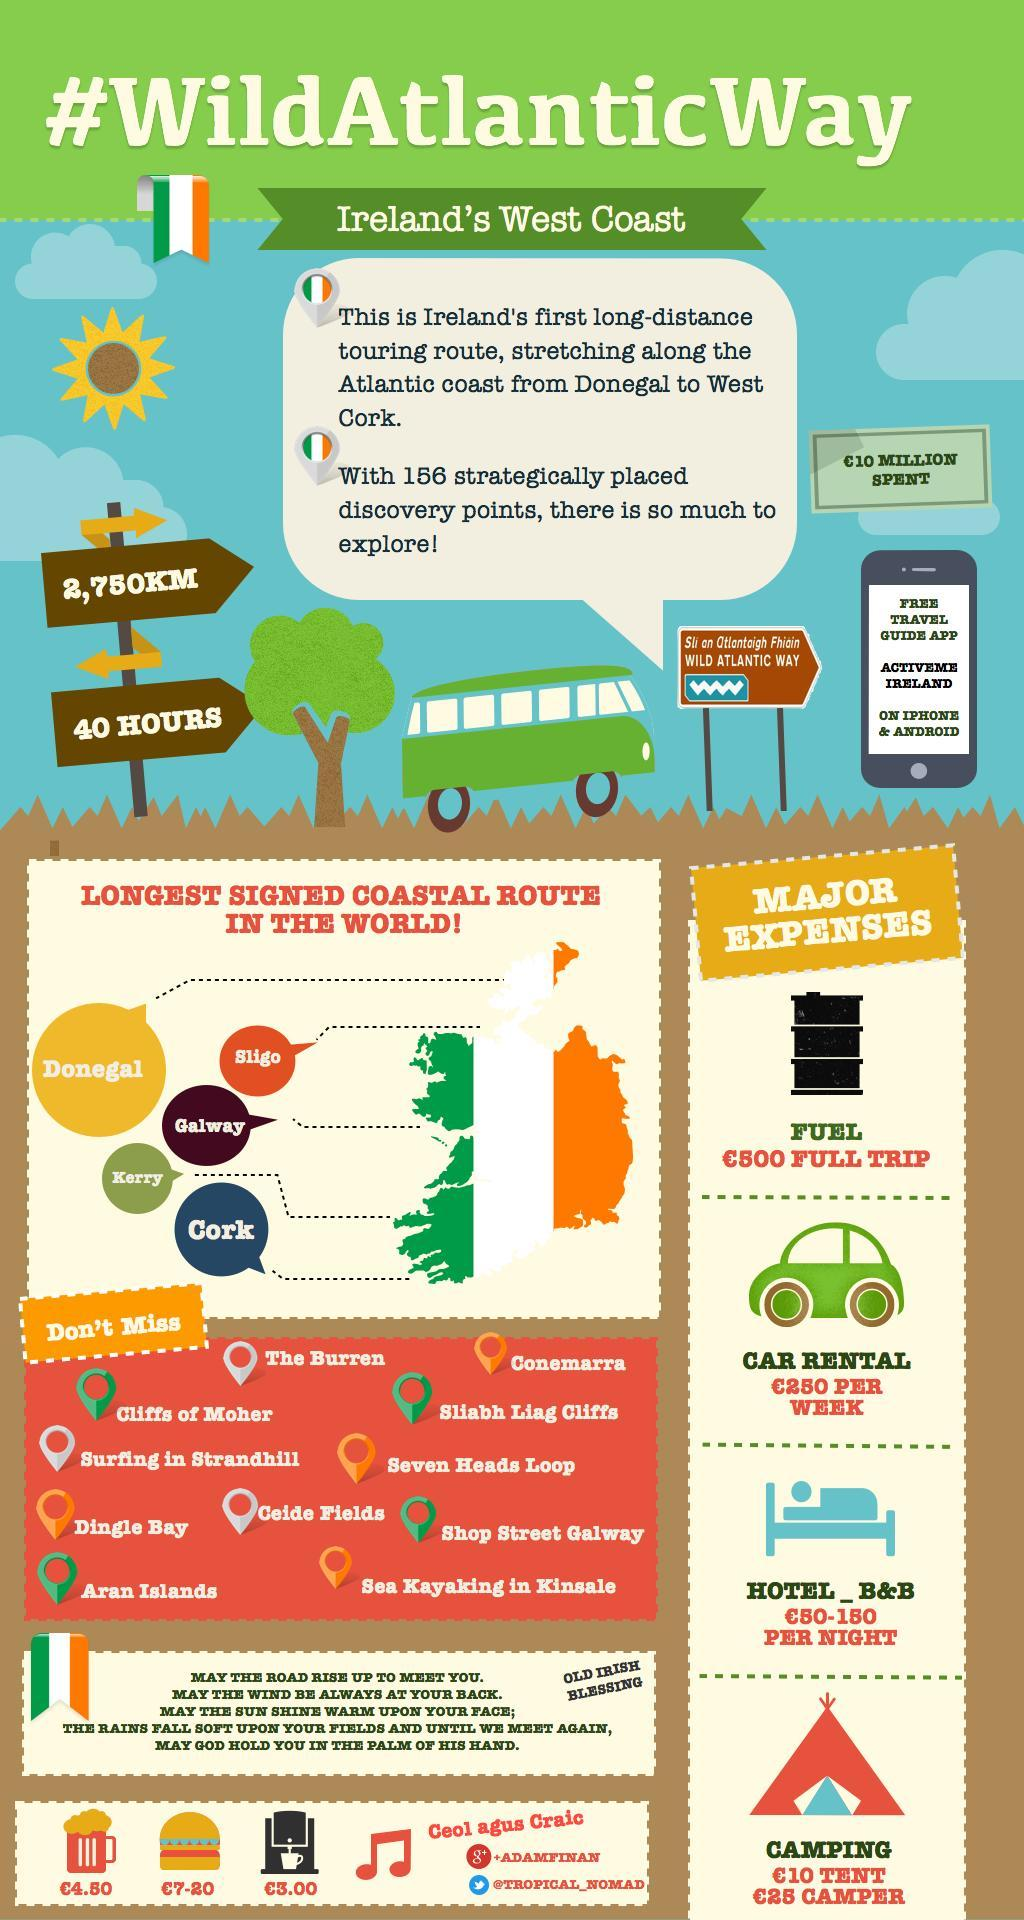How much time will the route take?
Answer the question with a short phrase. 40 HOURS How long is the touring route? 2,750KM How many major expenses are to be taken care of? 4 